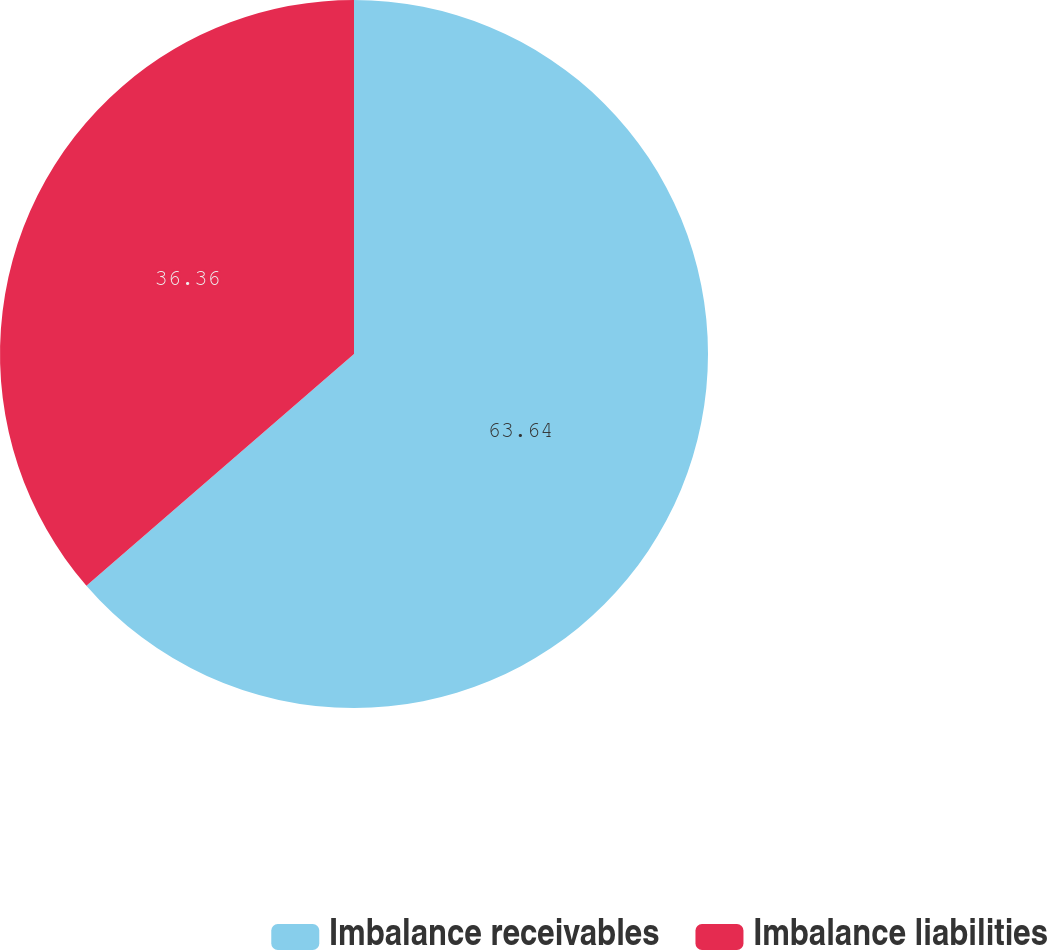Convert chart to OTSL. <chart><loc_0><loc_0><loc_500><loc_500><pie_chart><fcel>Imbalance receivables<fcel>Imbalance liabilities<nl><fcel>63.64%<fcel>36.36%<nl></chart> 